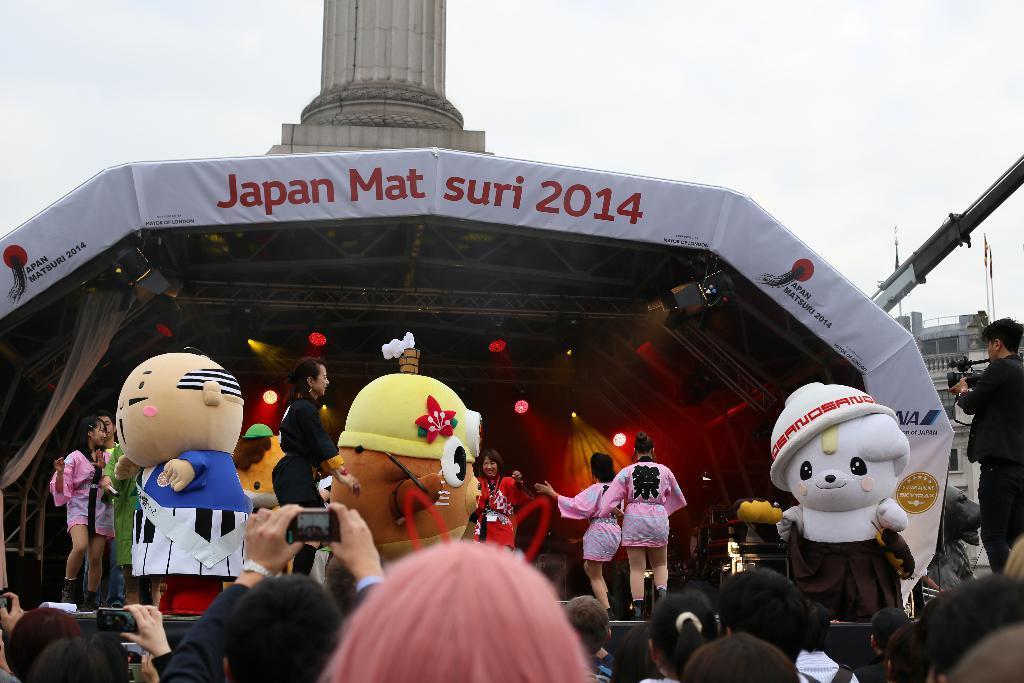Describe this image in one or two sentences. This image consists of many people. On the dais there are six women dancing. In the front, there are three persons wearing costume. In the background, there is a shed. 